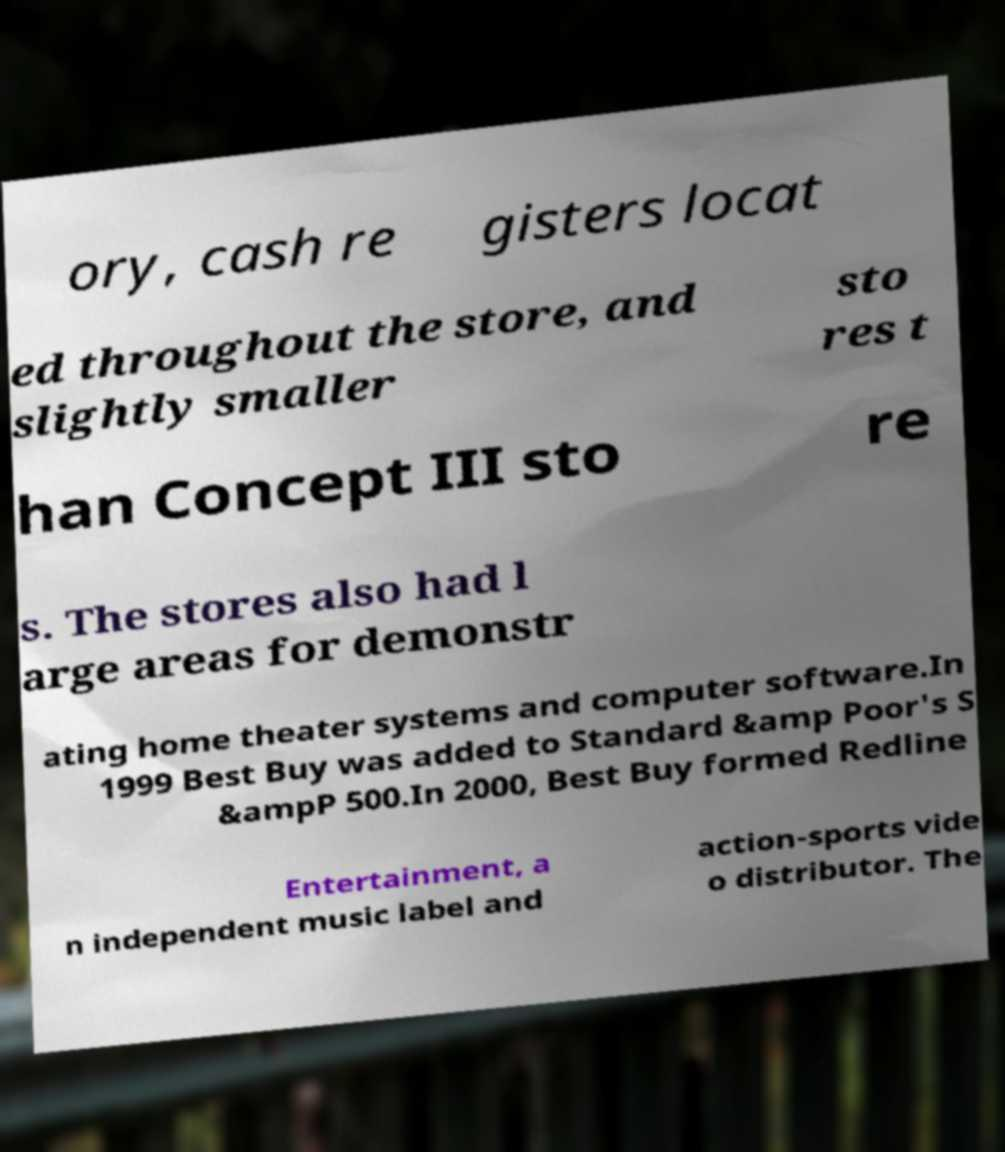Could you assist in decoding the text presented in this image and type it out clearly? ory, cash re gisters locat ed throughout the store, and slightly smaller sto res t han Concept III sto re s. The stores also had l arge areas for demonstr ating home theater systems and computer software.In 1999 Best Buy was added to Standard &amp Poor's S &ampP 500.In 2000, Best Buy formed Redline Entertainment, a n independent music label and action-sports vide o distributor. The 